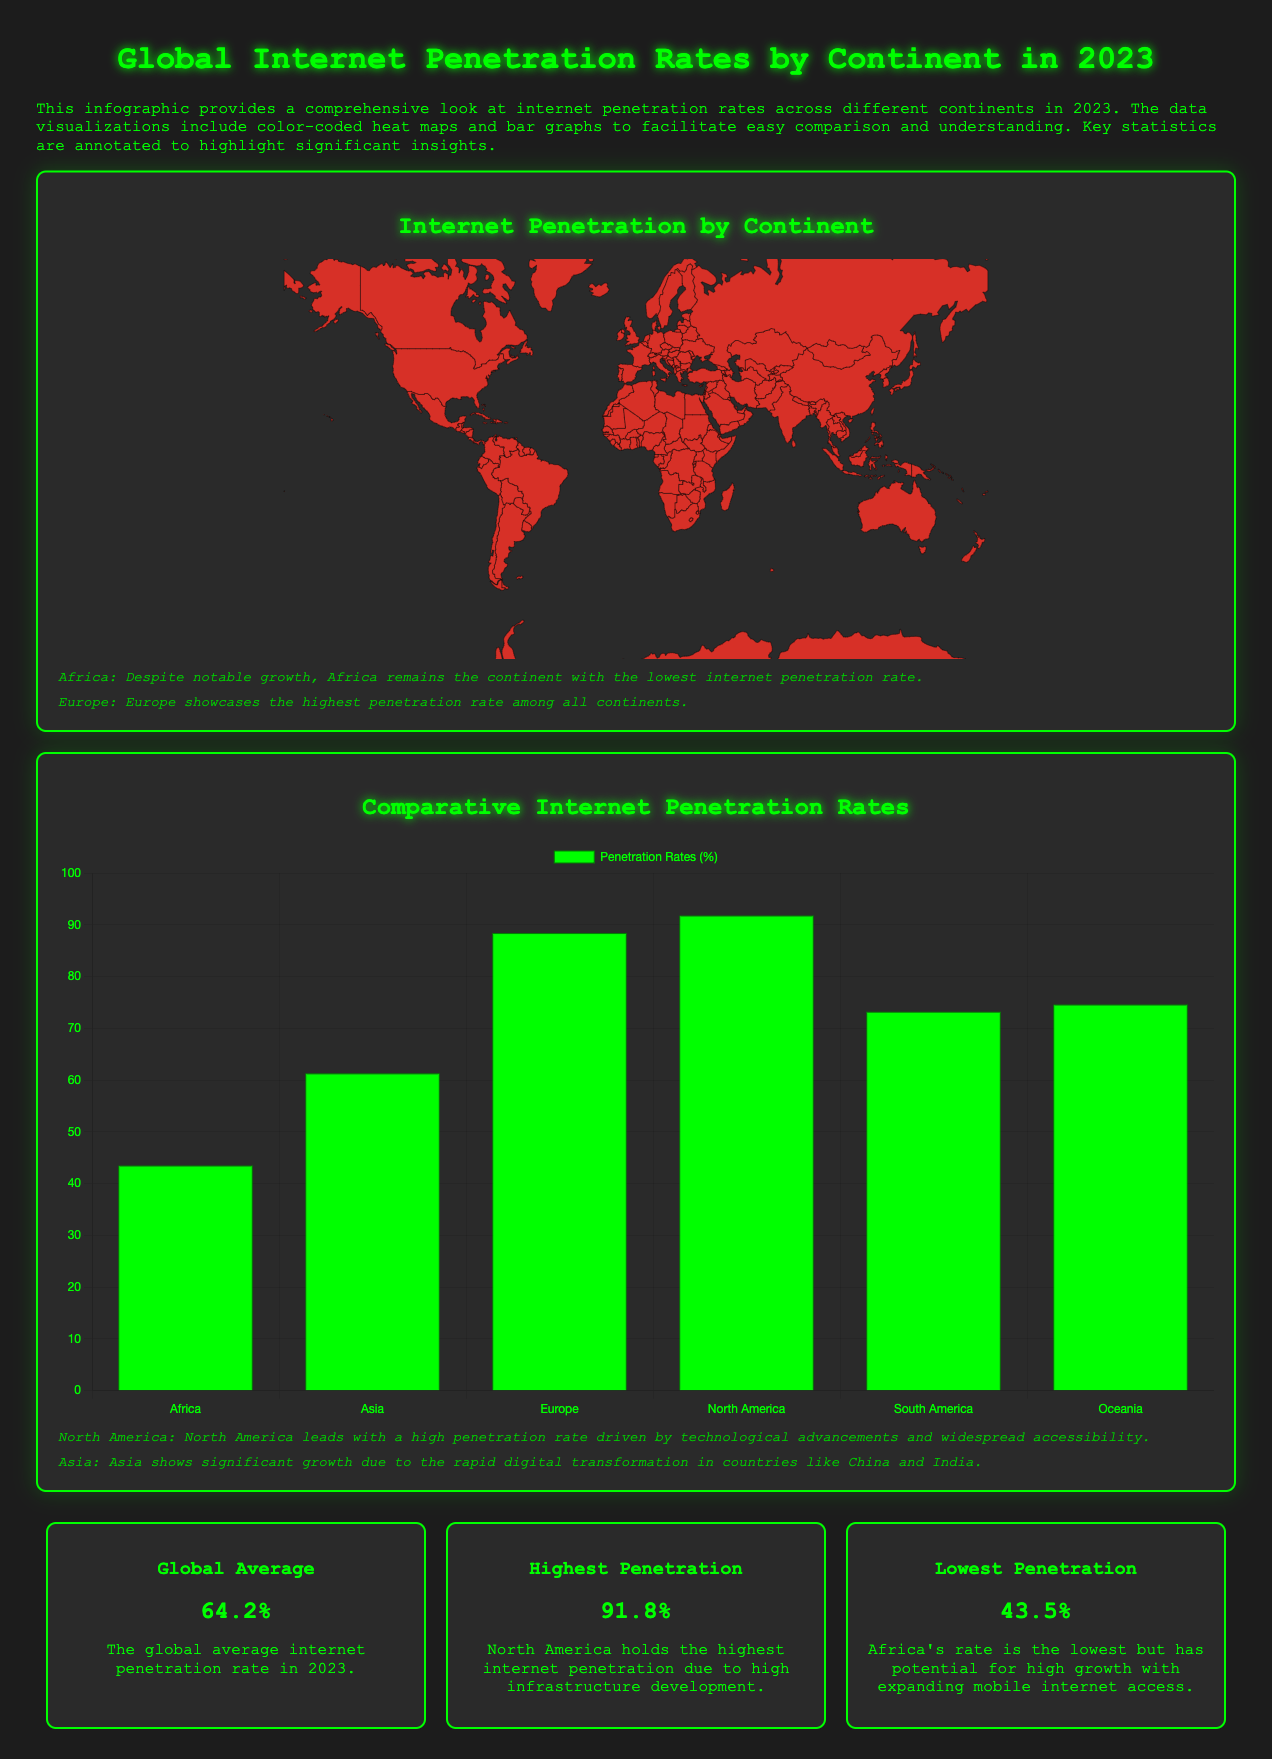What is the global average internet penetration rate in 2023? The document states the global average internet penetration rate in 2023 is highlighted in a stat box.
Answer: 64.2% Which continent has the highest internet penetration rate? The infographic includes a stat box stating which continent holds the highest rate, driven by infrastructure development.
Answer: North America What is Africa's internet penetration rate? The heat map indicates Africa's internet penetration rate, which is specifically mentioned in the annotations.
Answer: 43.5% What percentage of internet penetration does Europe have? The document includes a specific stat box detailing the internet penetration rate for Europe.
Answer: 88.4% Which continent shows significant growth due to digital transformation? The annotations provide insights on which continent is experiencing notable growth due to advancements in technology.
Answer: Asia What is the internet penetration rate of Oceania? The bar graph lists the penetration rates for different continents, including Oceania.
Answer: 74.6% What color represents the lowest internet penetration rates on the heat map? The color scale provided in the document describes the colors corresponding to different internet penetration rates, identifying the lowest rates.
Answer: Red What is the total number of continents shown in the infographic? The bar graph and the heat map display data for various continents, which can be counted.
Answer: Six 